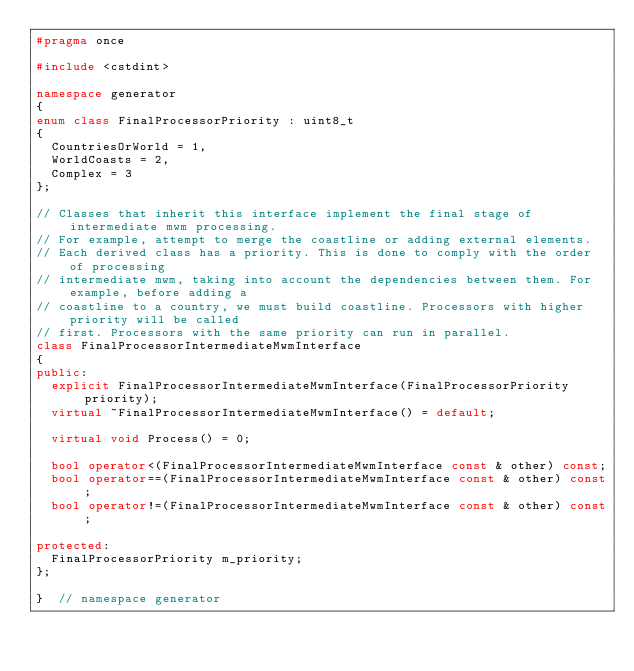Convert code to text. <code><loc_0><loc_0><loc_500><loc_500><_C++_>#pragma once

#include <cstdint>

namespace generator
{
enum class FinalProcessorPriority : uint8_t
{
  CountriesOrWorld = 1,
  WorldCoasts = 2,
  Complex = 3
};

// Classes that inherit this interface implement the final stage of intermediate mwm processing.
// For example, attempt to merge the coastline or adding external elements.
// Each derived class has a priority. This is done to comply with the order of processing
// intermediate mwm, taking into account the dependencies between them. For example, before adding a
// coastline to a country, we must build coastline. Processors with higher priority will be called
// first. Processors with the same priority can run in parallel.
class FinalProcessorIntermediateMwmInterface
{
public:
  explicit FinalProcessorIntermediateMwmInterface(FinalProcessorPriority priority);
  virtual ~FinalProcessorIntermediateMwmInterface() = default;

  virtual void Process() = 0;

  bool operator<(FinalProcessorIntermediateMwmInterface const & other) const;
  bool operator==(FinalProcessorIntermediateMwmInterface const & other) const;
  bool operator!=(FinalProcessorIntermediateMwmInterface const & other) const;

protected:
  FinalProcessorPriority m_priority;
};

}  // namespace generator
</code> 